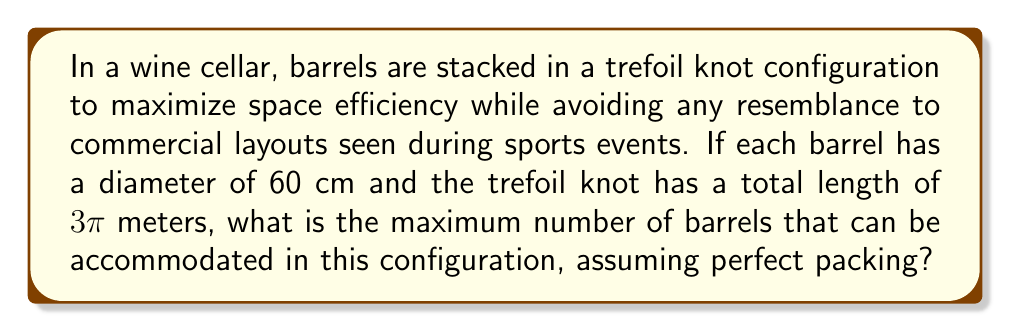Show me your answer to this math problem. Let's approach this step-by-step:

1) First, we need to understand the trefoil knot. It's a knot with three crossings and can be represented by the equation:

   $$x = \sin t + 2 \sin 2t$$
   $$y = \cos t - 2 \cos 2t$$
   $$z = -\sin 3t$$

   where $0 \leq t \leq 2\pi$

2) We're given that the total length of the trefoil knot is $3\pi$ meters.

3) Each barrel has a diameter of 60 cm = 0.6 m.

4) To find the number of barrels, we need to divide the total length by the diameter:

   $$\text{Number of barrels} = \frac{\text{Total length}}{\text{Barrel diameter}}$$

5) Substituting the values:

   $$\text{Number of barrels} = \frac{3\pi \text{ m}}{0.6 \text{ m}}$$

6) Simplifying:

   $$\text{Number of barrels} = 5\pi$$

7) Since we can't have a fractional number of barrels, we need to round down to the nearest whole number:

   $$\text{Number of barrels} = \lfloor 5\pi \rfloor = 15$$

Therefore, the maximum number of barrels that can be accommodated in this trefoil knot configuration is 15.
Answer: 15 barrels 